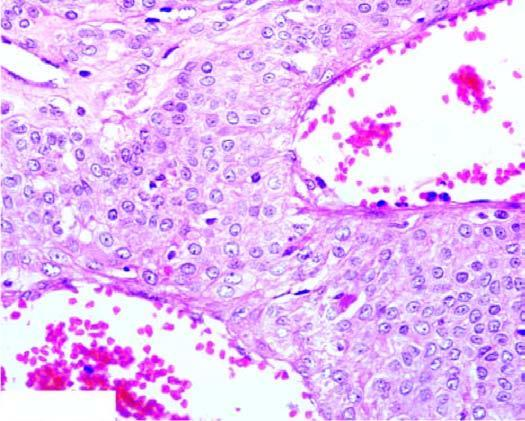what are there lined by endothelial cells and surrounded by nests and masses of glomus cells?
Answer the question using a single word or phrase. Blood-filled vascular channels 